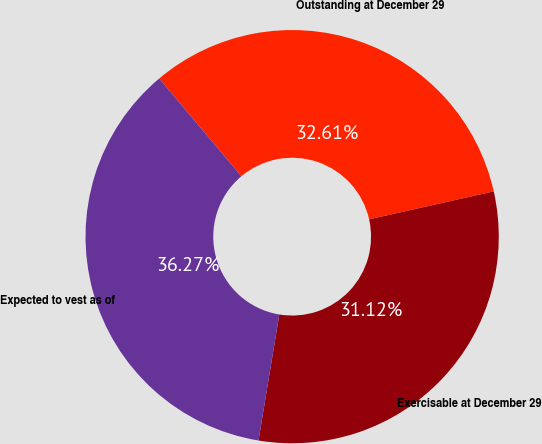Convert chart. <chart><loc_0><loc_0><loc_500><loc_500><pie_chart><fcel>Outstanding at December 29<fcel>Exercisable at December 29<fcel>Expected to vest as of<nl><fcel>32.61%<fcel>31.12%<fcel>36.27%<nl></chart> 